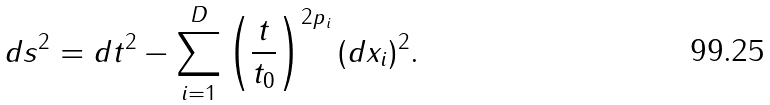Convert formula to latex. <formula><loc_0><loc_0><loc_500><loc_500>d s ^ { 2 } = d t ^ { 2 } - \sum _ { i = 1 } ^ { D } \left ( \frac { t } { t _ { 0 } } \right ) ^ { 2 p _ { i } } ( d x _ { i } ) ^ { 2 } .</formula> 